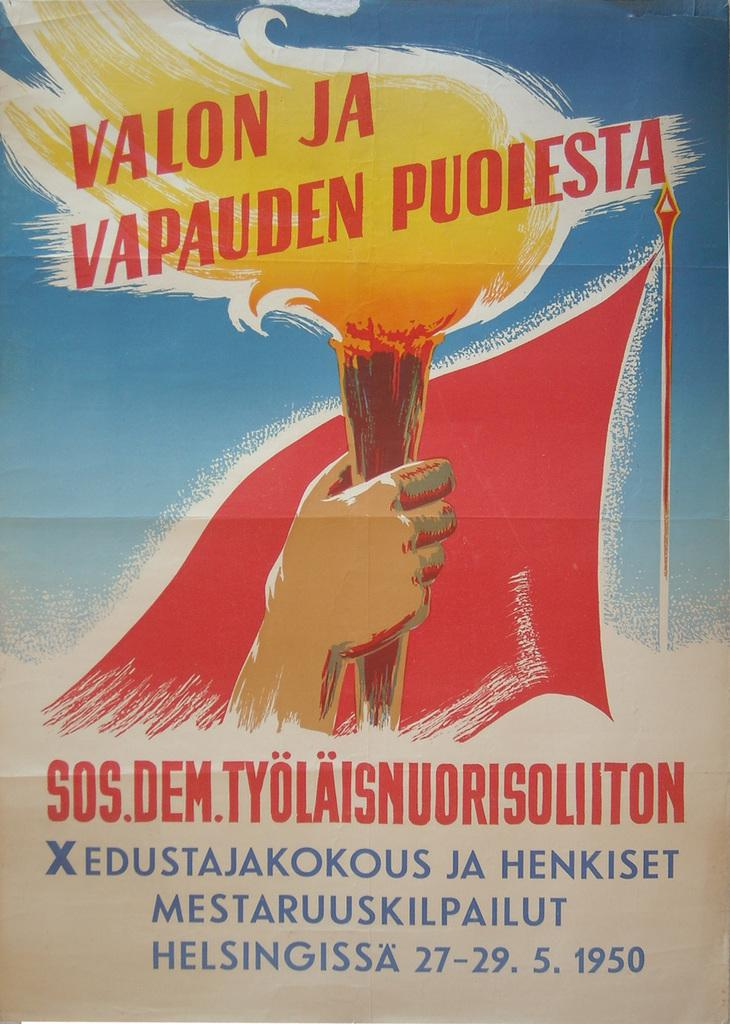Provide a one-sentence caption for the provided image. A poster advertises an event dated 27-29. 5. 1950. 